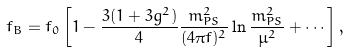<formula> <loc_0><loc_0><loc_500><loc_500>f _ { B } = f _ { 0 } \left [ 1 - \frac { 3 ( 1 + 3 g ^ { 2 } ) } { 4 } \frac { m ^ { 2 } _ { P S } } { ( 4 \pi f ) ^ { 2 } } \ln \frac { m ^ { 2 } _ { P S } } { \mu ^ { 2 } } + \cdots \right ] ,</formula> 